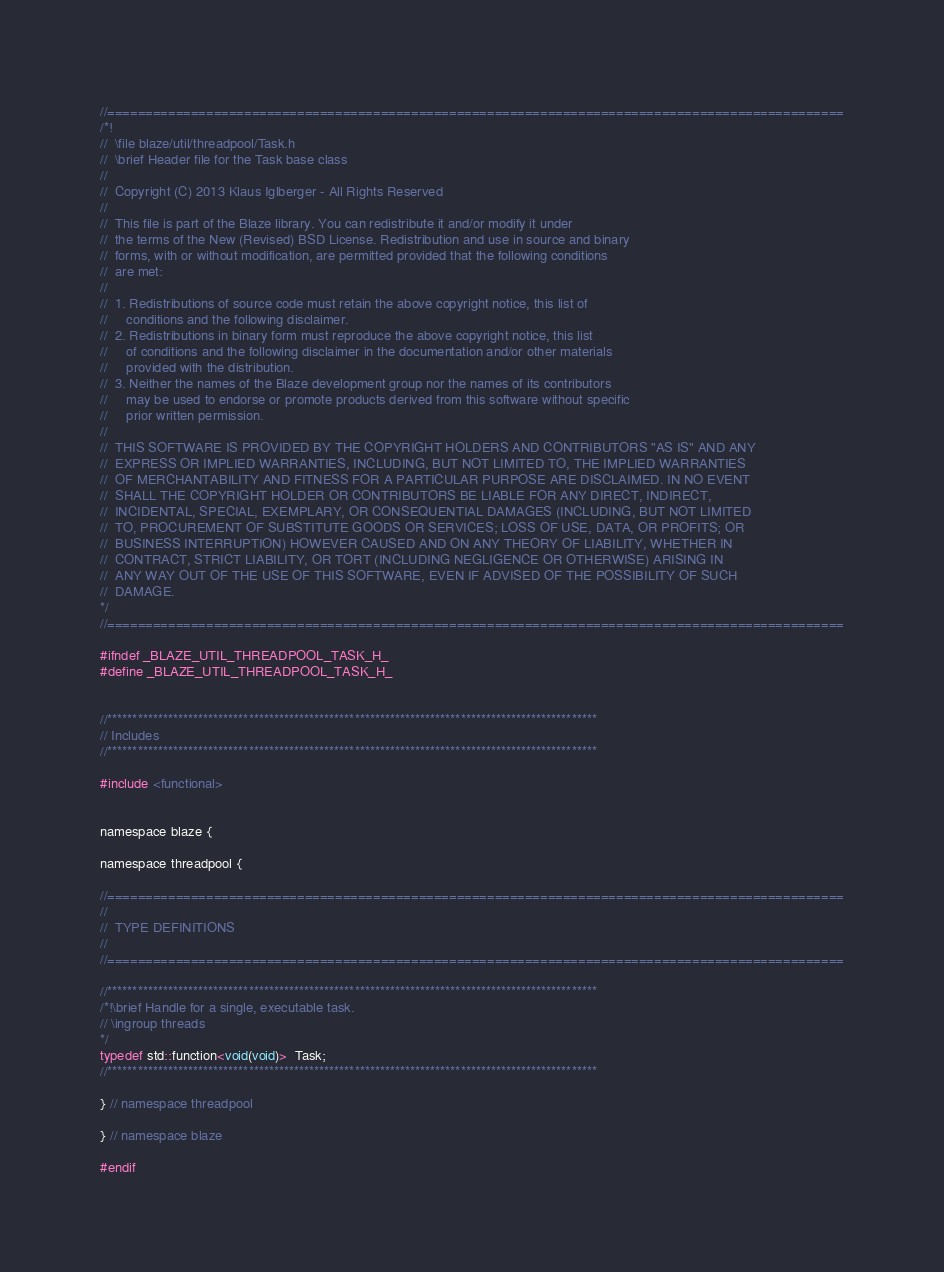Convert code to text. <code><loc_0><loc_0><loc_500><loc_500><_C_>//=================================================================================================
/*!
//  \file blaze/util/threadpool/Task.h
//  \brief Header file for the Task base class
//
//  Copyright (C) 2013 Klaus Iglberger - All Rights Reserved
//
//  This file is part of the Blaze library. You can redistribute it and/or modify it under
//  the terms of the New (Revised) BSD License. Redistribution and use in source and binary
//  forms, with or without modification, are permitted provided that the following conditions
//  are met:
//
//  1. Redistributions of source code must retain the above copyright notice, this list of
//     conditions and the following disclaimer.
//  2. Redistributions in binary form must reproduce the above copyright notice, this list
//     of conditions and the following disclaimer in the documentation and/or other materials
//     provided with the distribution.
//  3. Neither the names of the Blaze development group nor the names of its contributors
//     may be used to endorse or promote products derived from this software without specific
//     prior written permission.
//
//  THIS SOFTWARE IS PROVIDED BY THE COPYRIGHT HOLDERS AND CONTRIBUTORS "AS IS" AND ANY
//  EXPRESS OR IMPLIED WARRANTIES, INCLUDING, BUT NOT LIMITED TO, THE IMPLIED WARRANTIES
//  OF MERCHANTABILITY AND FITNESS FOR A PARTICULAR PURPOSE ARE DISCLAIMED. IN NO EVENT
//  SHALL THE COPYRIGHT HOLDER OR CONTRIBUTORS BE LIABLE FOR ANY DIRECT, INDIRECT,
//  INCIDENTAL, SPECIAL, EXEMPLARY, OR CONSEQUENTIAL DAMAGES (INCLUDING, BUT NOT LIMITED
//  TO, PROCUREMENT OF SUBSTITUTE GOODS OR SERVICES; LOSS OF USE, DATA, OR PROFITS; OR
//  BUSINESS INTERRUPTION) HOWEVER CAUSED AND ON ANY THEORY OF LIABILITY, WHETHER IN
//  CONTRACT, STRICT LIABILITY, OR TORT (INCLUDING NEGLIGENCE OR OTHERWISE) ARISING IN
//  ANY WAY OUT OF THE USE OF THIS SOFTWARE, EVEN IF ADVISED OF THE POSSIBILITY OF SUCH
//  DAMAGE.
*/
//=================================================================================================

#ifndef _BLAZE_UTIL_THREADPOOL_TASK_H_
#define _BLAZE_UTIL_THREADPOOL_TASK_H_


//*************************************************************************************************
// Includes
//*************************************************************************************************

#include <functional>


namespace blaze {

namespace threadpool {

//=================================================================================================
//
//  TYPE DEFINITIONS
//
//=================================================================================================

//*************************************************************************************************
/*!\brief Handle for a single, executable task.
// \ingroup threads
*/
typedef std::function<void(void)>  Task;
//*************************************************************************************************

} // namespace threadpool

} // namespace blaze

#endif
</code> 